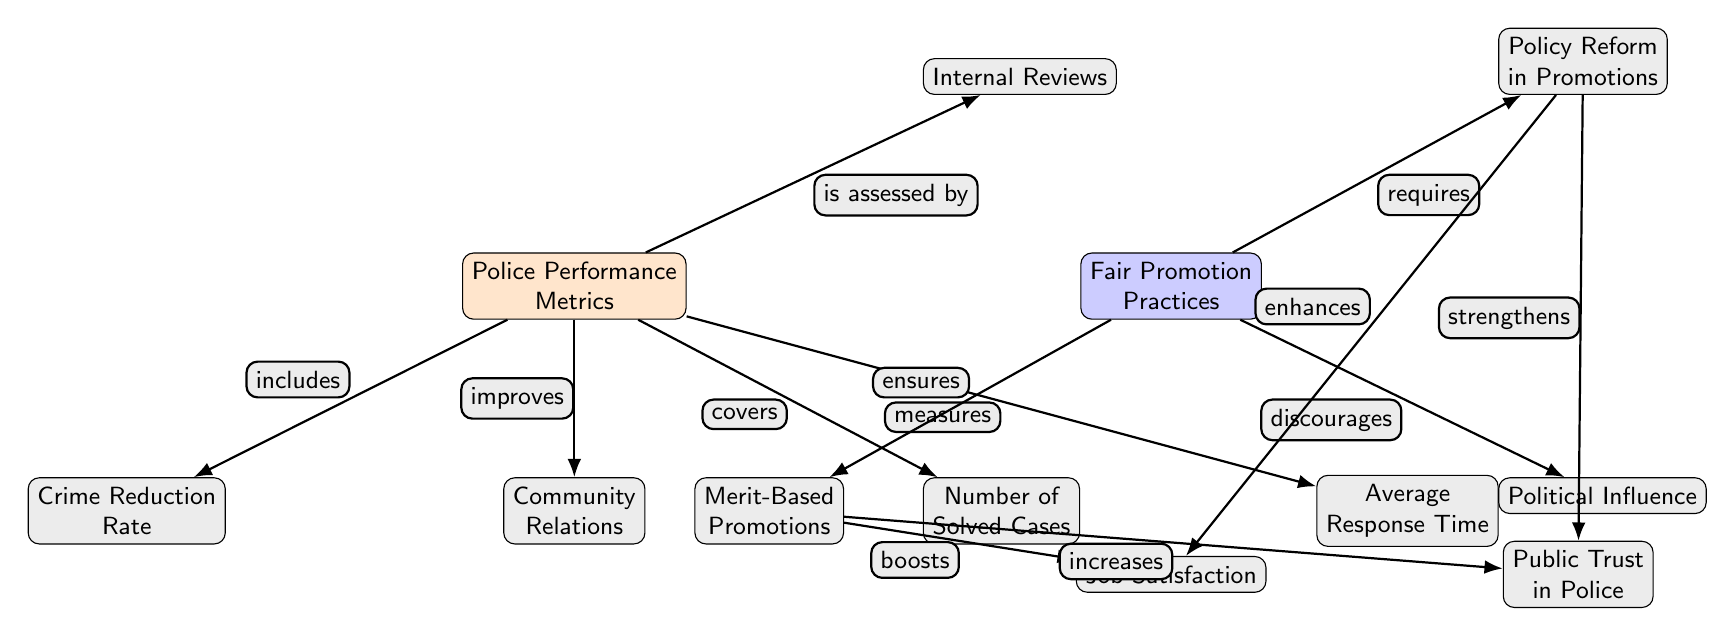what are the main categories of metrics influencing police performance? The main categories of metrics influencing police performance are Crime Reduction Rate, Community Relations, Number of Solved Cases, Average Response Time, and Internal Reviews. These are directly connected as sub-nodes to the "Police Performance Metrics" node in the diagram.
Answer: Crime Reduction Rate, Community Relations, Number of Solved Cases, Average Response Time, Internal Reviews how does merit-based promotions affect job satisfaction? According to the diagram, merit-based promotions boost job satisfaction. This relationship is illustrated by an edge from the "Merit-Based Promotions" node to the "Job Satisfaction" node, indicating a positive influence.
Answer: boosts what is the relationship between political influence and fair promotion practices? The diagram indicates that fair promotion practices discourage political influence. This is shown by the directed edge from "Fair Promotion Practices" to "Political Influence," signifying a negative correlation.
Answer: discourages how many nodes are there in total in the diagram? There are ten nodes in total in the diagram. By counting each node separately, including both the performance metrics and fair promotion practices categories, we find the total.
Answer: 10 what impacts does policy reform have on public trust? The diagram shows that policy reform strengthens public trust. This is demonstrated by the edge directed from the "Policy Reform in Promotions" node to the "Public Trust in Police" node, which denotes a positive effect.
Answer: strengthens which node is assessed by internal reviews? The "Police Performance Metrics" node is assessed by internal reviews, as indicated by the connecting edge labeled "is assessed by" leading to the "Internal Reviews" node.
Answer: Police Performance Metrics how does community relations relate to police performance metrics? Community relations improve police performance metrics, as shown by the edge labeled "improves" from the "Police Performance Metrics" node to the "Community Relations" node. This indicates a beneficial relationship.
Answer: improves what is the impact of merit-based promotions on public trust? The diagram illustrates that merit-based promotions increase public trust, as shown by the directed edge from "Merit-Based Promotions" to "Public Trust in Police." This shows a direct positive effect.
Answer: increases 